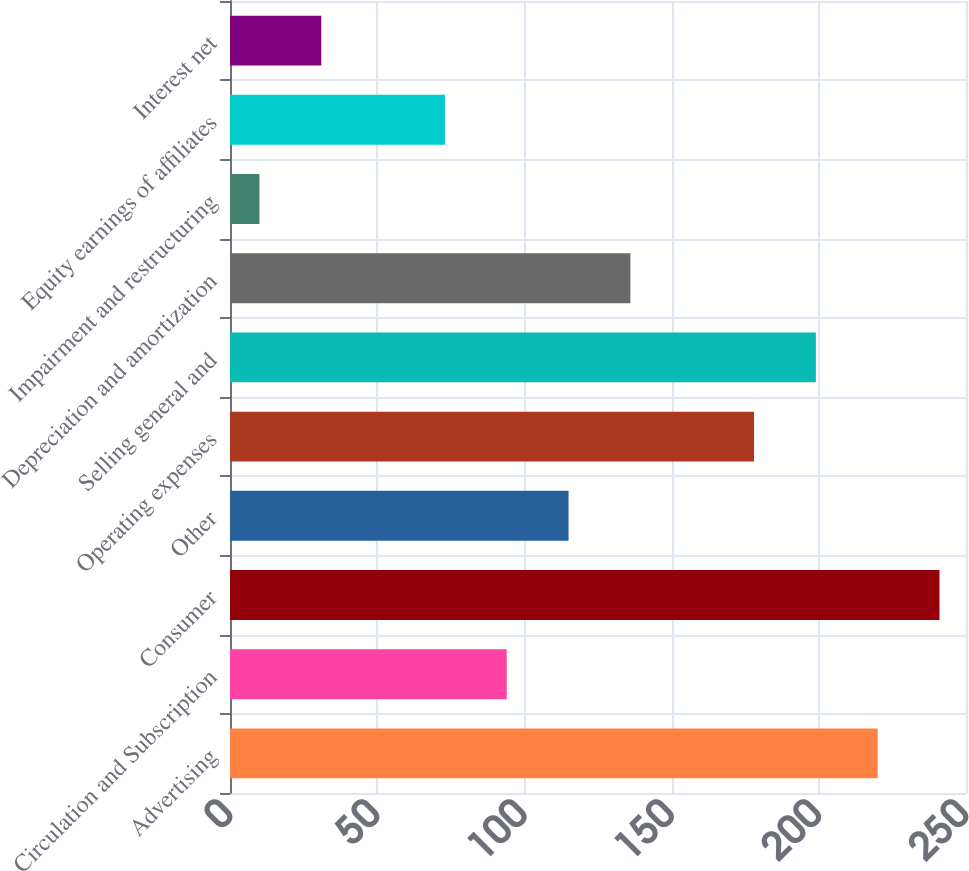Convert chart. <chart><loc_0><loc_0><loc_500><loc_500><bar_chart><fcel>Advertising<fcel>Circulation and Subscription<fcel>Consumer<fcel>Other<fcel>Operating expenses<fcel>Selling general and<fcel>Depreciation and amortization<fcel>Impairment and restructuring<fcel>Equity earnings of affiliates<fcel>Interest net<nl><fcel>220<fcel>94<fcel>241<fcel>115<fcel>178<fcel>199<fcel>136<fcel>10<fcel>73<fcel>31<nl></chart> 